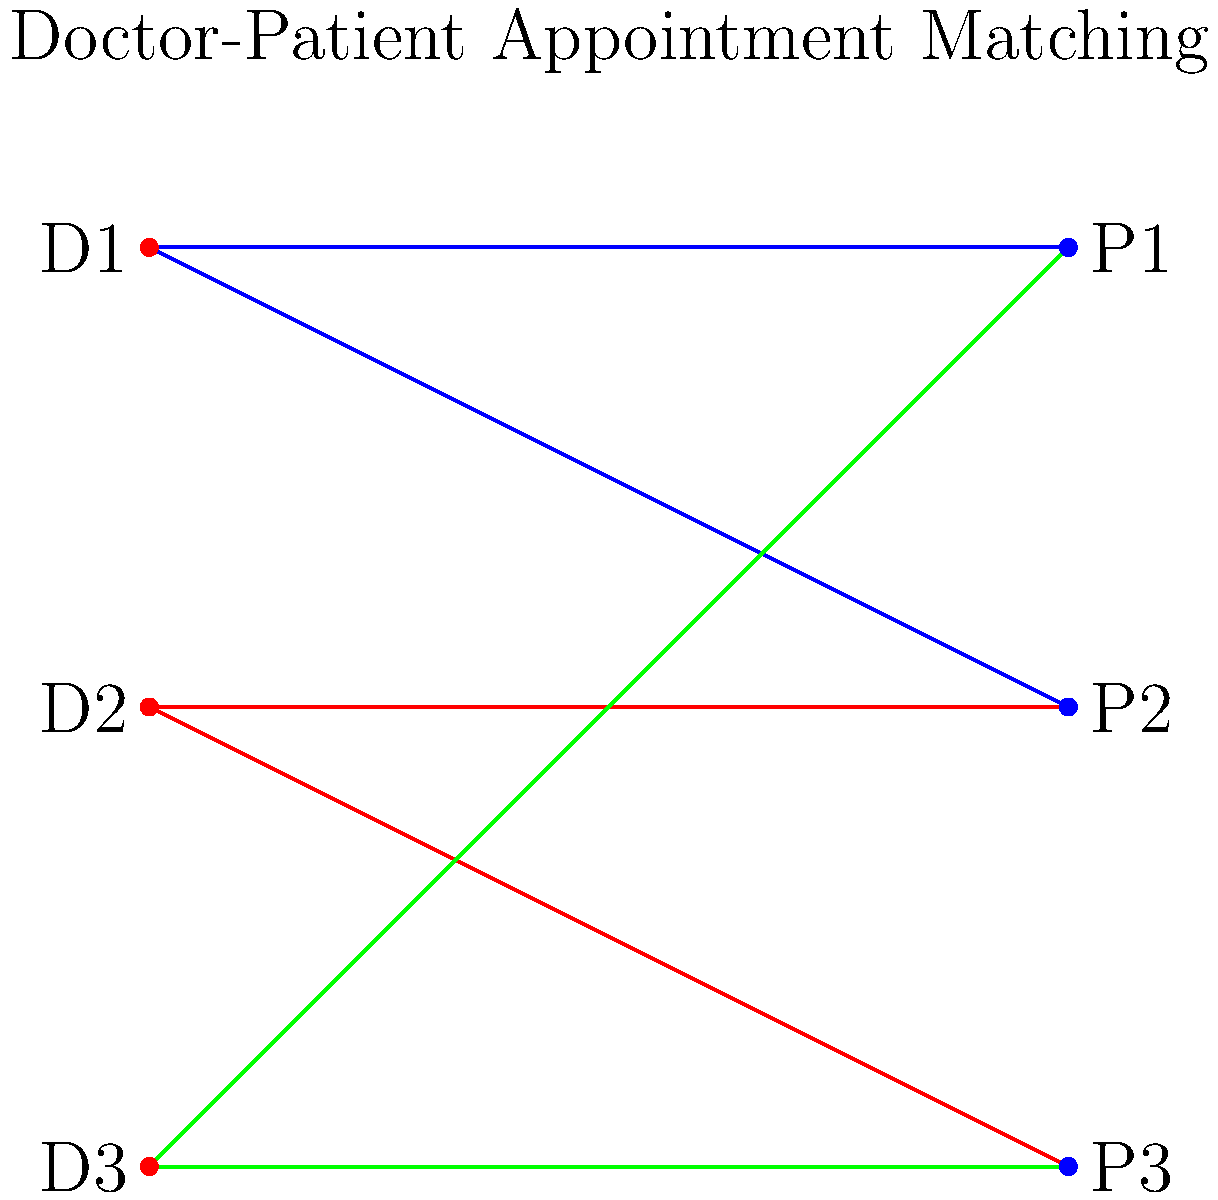In a local clinic, three doctors (D1, D2, D3) need to be matched with three patients (P1, P2, P3) for appointments. The bipartite graph above shows the possible matches, where an edge indicates that a doctor is available for a patient's preferred time slot. Using the maximum bipartite matching algorithm, what is the maximum number of appointments that can be scheduled, and which doctor-patient pairs form this optimal matching? To solve this problem, we'll use the maximum bipartite matching algorithm:

1. Initialize an empty matching set.

2. For each unmatched doctor, try to find an augmenting path:
   a. D1 can match with P1. Add (D1, P1) to the matching.
   b. D2 can match with P2. Add (D2, P2) to the matching.
   c. D3 can only match with P1 or P3, but P1 is already matched. Try P3.
      Add (D3, P3) to the matching.

3. No more augmenting paths can be found.

4. The final matching includes:
   (D1, P1), (D2, P2), and (D3, P3)

5. Count the number of matches: 3

Therefore, the maximum number of appointments that can be scheduled is 3, and the optimal matching pairs are (D1, P1), (D2, P2), and (D3, P3).
Answer: 3 appointments; (D1, P1), (D2, P2), (D3, P3) 